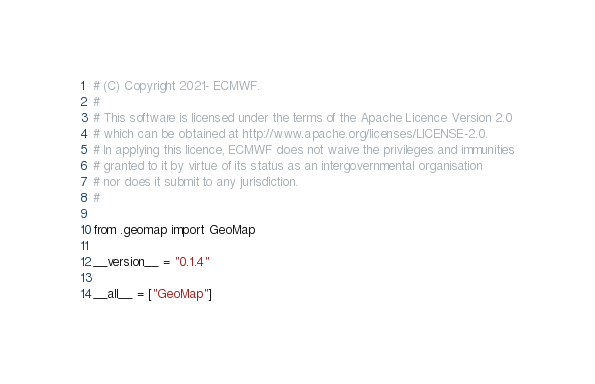Convert code to text. <code><loc_0><loc_0><loc_500><loc_500><_Python_># (C) Copyright 2021- ECMWF.
#
# This software is licensed under the terms of the Apache Licence Version 2.0
# which can be obtained at http://www.apache.org/licenses/LICENSE-2.0.
# In applying this licence, ECMWF does not waive the privileges and immunities
# granted to it by virtue of its status as an intergovernmental organisation
# nor does it submit to any jurisdiction.
#

from .geomap import GeoMap

__version__ = "0.1.4"

__all__ = ["GeoMap"]
</code> 